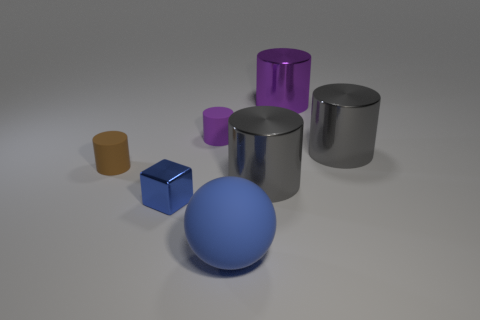Subtract all blue cylinders. Subtract all green spheres. How many cylinders are left? 5 Add 3 large green shiny cubes. How many objects exist? 10 Subtract all balls. How many objects are left? 6 Subtract 1 blue spheres. How many objects are left? 6 Subtract all large purple metallic cylinders. Subtract all brown rubber objects. How many objects are left? 5 Add 1 big purple objects. How many big purple objects are left? 2 Add 1 blue metal cubes. How many blue metal cubes exist? 2 